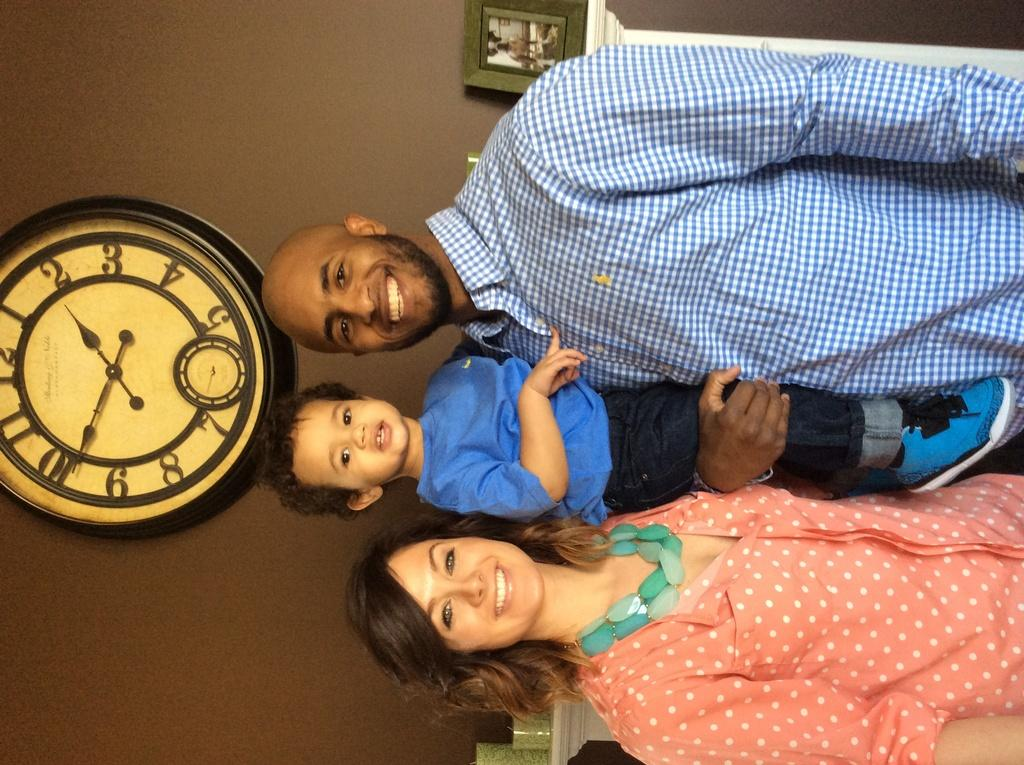Who are the people present in the image? There is a lady, a kid, and a man in the image. What can be seen on the wall in the image? There is a wall clock on the wall in the image. What objects are related to vision or sight in the image? There are glasses in the image. What is placed on a table in the image? There is a photo frame on a table in the image. What type of grape is being used as a paperweight in the image? There is no grape present in the image, let alone being used as a paperweight. What belief system is represented by the objects in the image? The image does not depict any specific belief system; it simply shows a lady, a kid, a man, a wall clock, glasses, and a photo frame. 